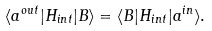Convert formula to latex. <formula><loc_0><loc_0><loc_500><loc_500>\langle a ^ { o u t } | H _ { i n t } | B \rangle = \langle B | H _ { i n t } | a ^ { i n } \rangle .</formula> 